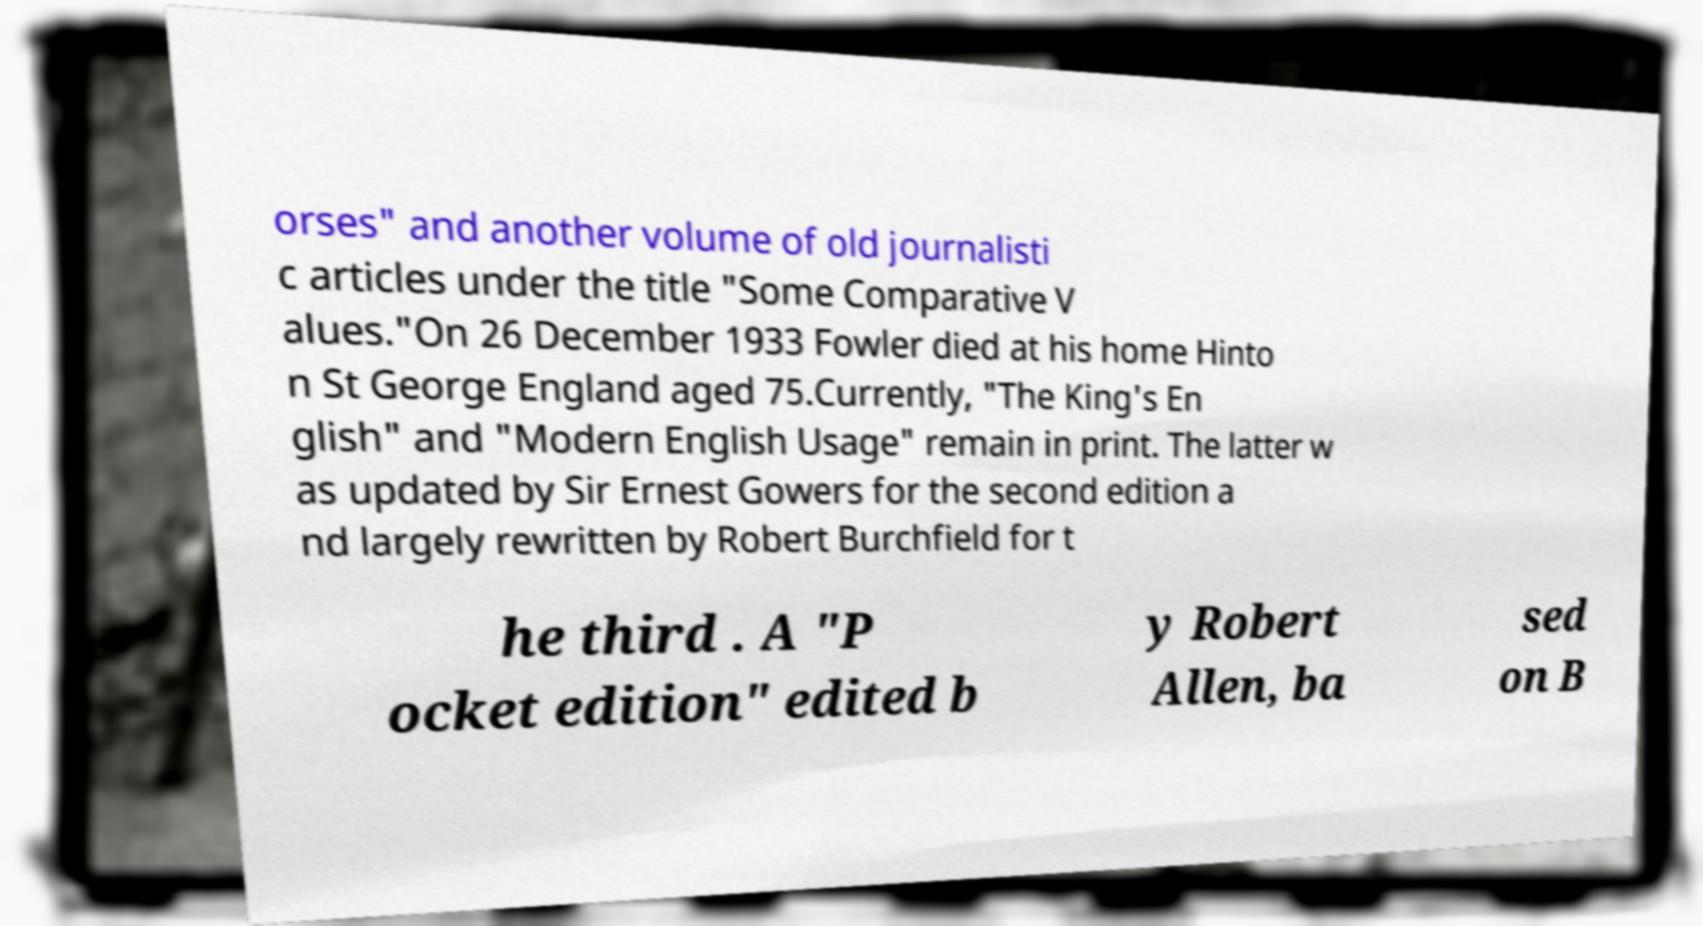I need the written content from this picture converted into text. Can you do that? orses" and another volume of old journalisti c articles under the title "Some Comparative V alues."On 26 December 1933 Fowler died at his home Hinto n St George England aged 75.Currently, "The King's En glish" and "Modern English Usage" remain in print. The latter w as updated by Sir Ernest Gowers for the second edition a nd largely rewritten by Robert Burchfield for t he third . A "P ocket edition" edited b y Robert Allen, ba sed on B 